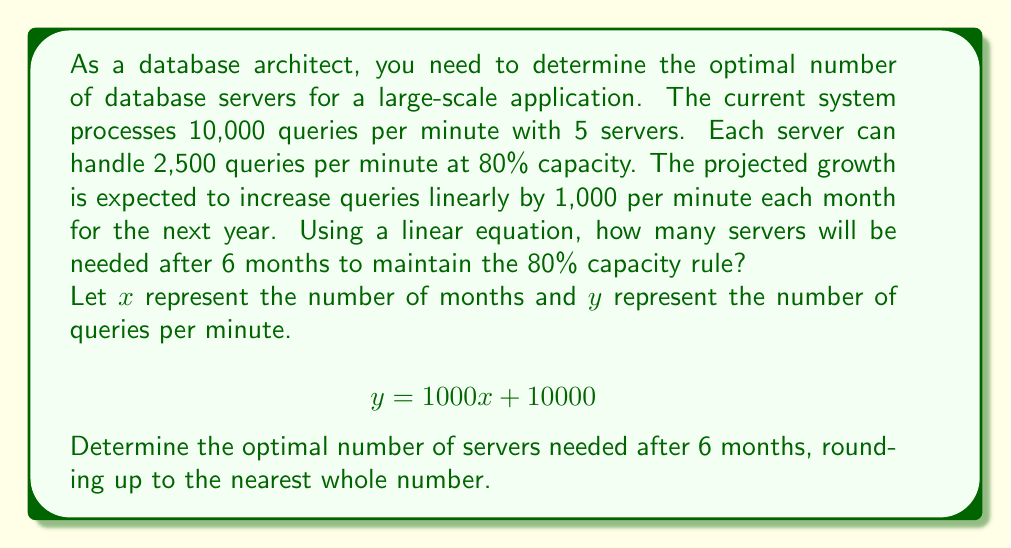Can you solve this math problem? To solve this problem, we'll follow these steps:

1. Calculate the number of queries after 6 months:
   Using the given equation: $y = 1000x + 10000$
   For $x = 6$ months: $y = 1000(6) + 10000 = 16000$ queries per minute

2. Calculate the number of queries a single server can handle at 80% capacity:
   Given: Each server can handle 2,500 queries at 80% capacity
   $2500 * 0.8 = 2000$ queries per server

3. Calculate the number of servers needed:
   $\text{Number of servers} = \frac{\text{Total queries}}{\text{Queries per server}}$
   
   $\text{Number of servers} = \frac{16000}{2000} = 8$

Since we need to round up to the nearest whole number (we can't have a fraction of a server), the optimal number of servers needed after 6 months is 8.

This solution ensures that the system can handle the projected query load while maintaining the 80% capacity rule, allowing for some headroom in case of unexpected spikes in traffic.
Answer: 8 servers 